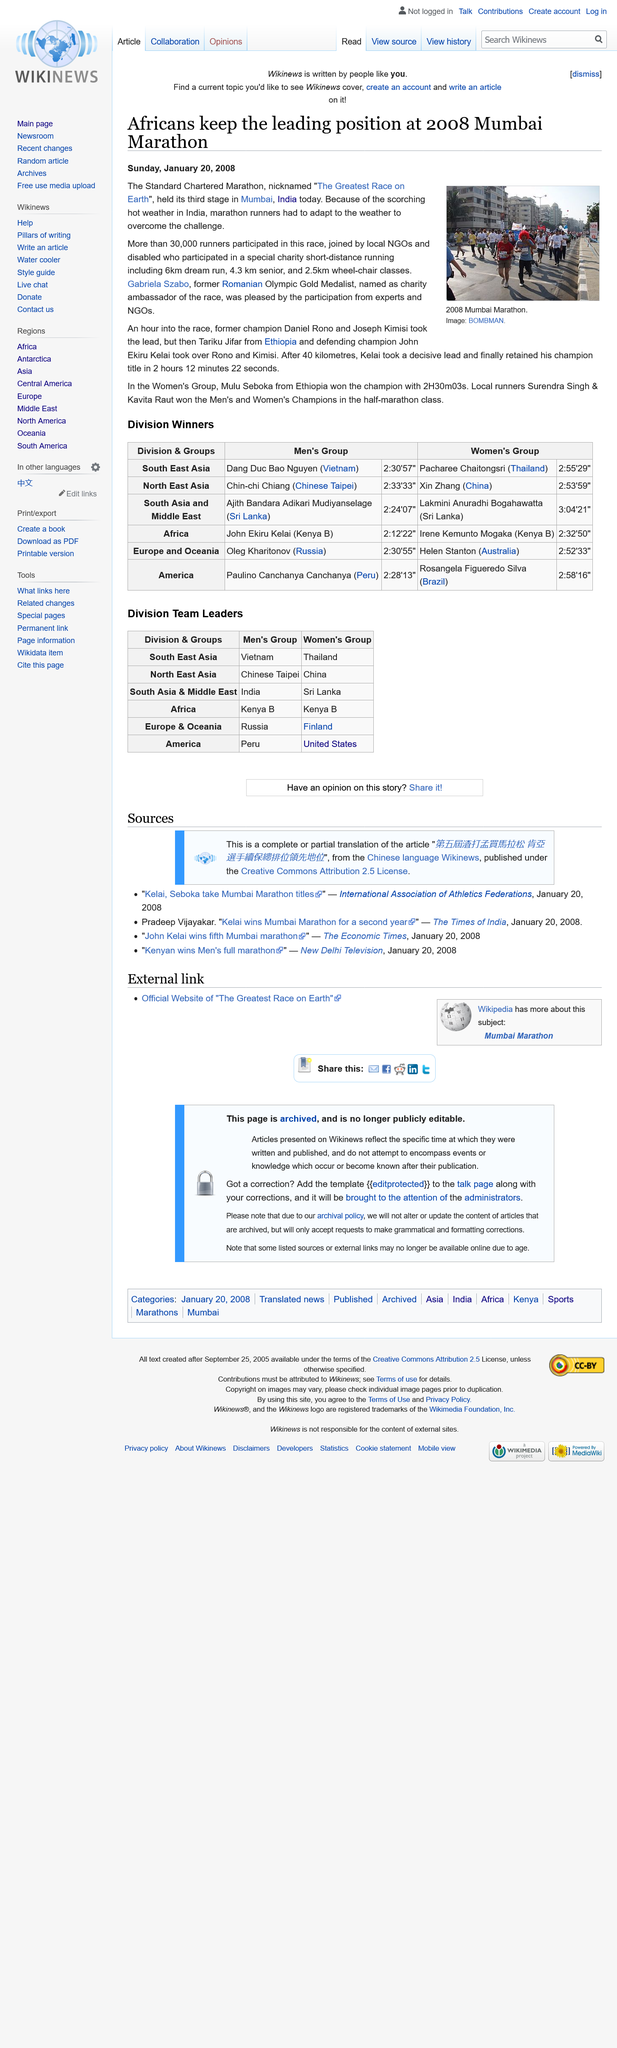Indicate a few pertinent items in this graphic. The 2008 Standard Chartered Marathon was participated by more than 30,000 people. The Standard Chartered Marathon is run in the city of Mumbai. Ekiru Kelai won the race in 2 hours 12 minutes and 22 seconds. 